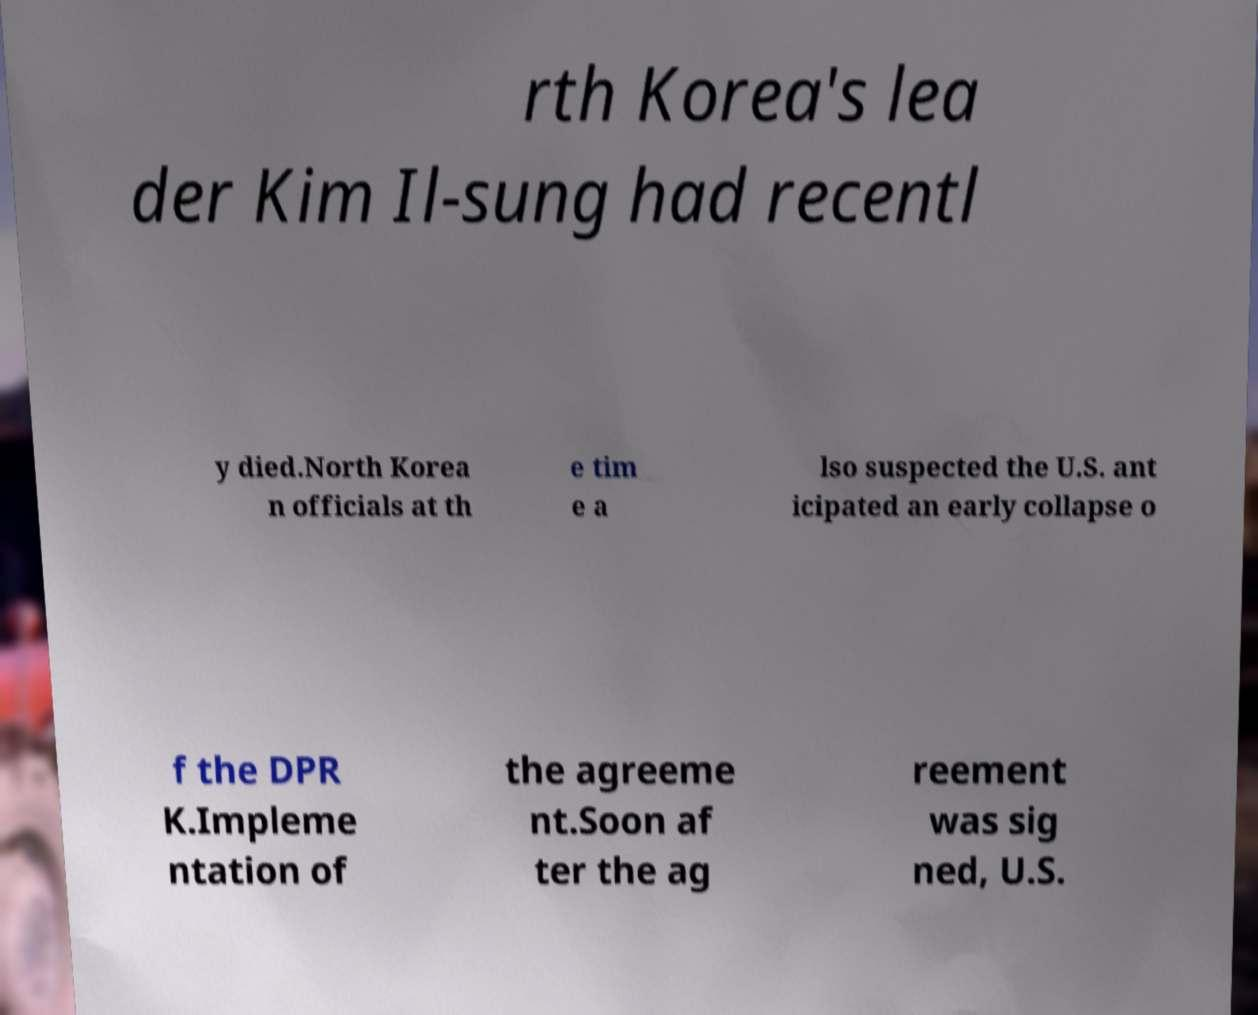There's text embedded in this image that I need extracted. Can you transcribe it verbatim? rth Korea's lea der Kim Il-sung had recentl y died.North Korea n officials at th e tim e a lso suspected the U.S. ant icipated an early collapse o f the DPR K.Impleme ntation of the agreeme nt.Soon af ter the ag reement was sig ned, U.S. 